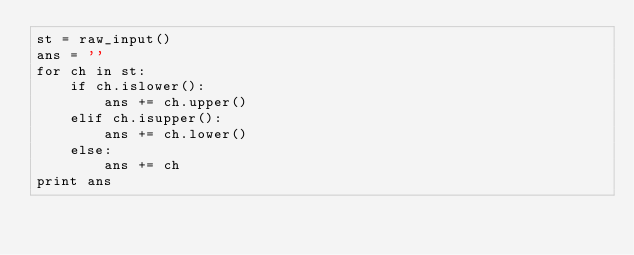<code> <loc_0><loc_0><loc_500><loc_500><_Python_>st = raw_input()
ans = ''
for ch in st:
    if ch.islower():
        ans += ch.upper()
    elif ch.isupper():
        ans += ch.lower()
    else:
        ans += ch
print ans</code> 